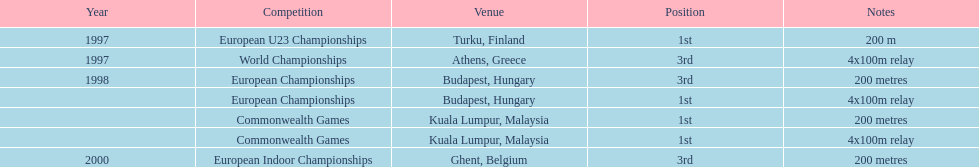How many instances was golding in the runner-up spot? 0. 